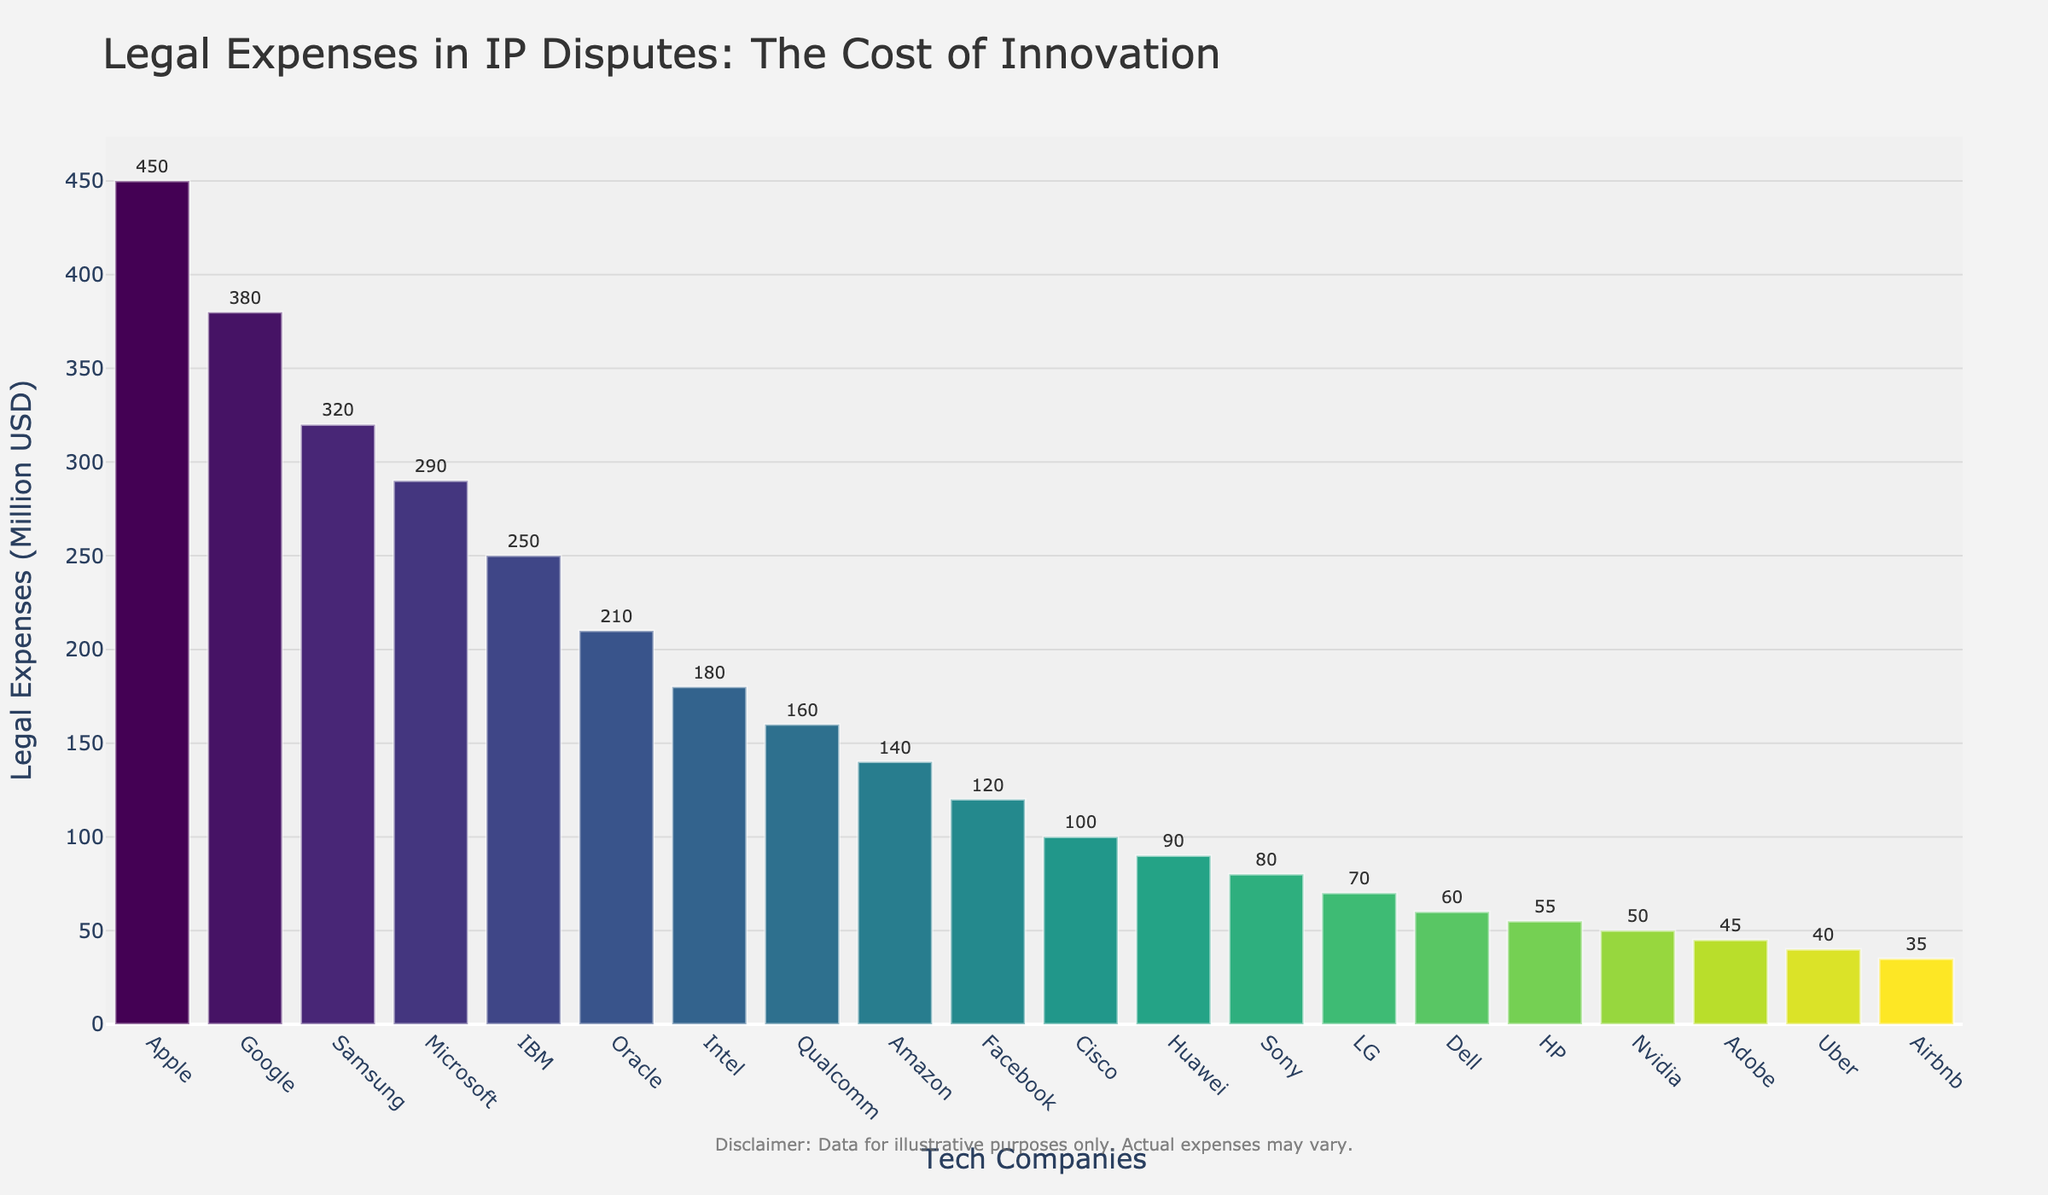What company has the highest legal expenses? The bar showing Apple is the tallest, indicating it has the highest legal expenses among the tech companies listed.
Answer: Apple What is the total legal expense for the top three companies? Add the legal expenses of Apple (450 Million USD), Google (380 Million USD), and Samsung (320 Million USD): 450 + 380 + 320 = 1150.
Answer: 1150 Among Facebook, Uber, and Airbnb, which company has the lowest legal expenses? Compare the legal expenses of the three companies: Facebook (120 Million USD), Uber (40 Million USD), and Airbnb (35 Million USD). The bar for Airbnb is the shortest among the three.
Answer: Airbnb Is Oracle's legal expense higher than Intel's? Oracle has 210 Million USD and Intel has 180 Million USD. Since 210 > 180, Oracle's legal expense is higher.
Answer: Yes What's the average legal expense for Amazon, Facebook, and Cisco? Sum the legal expenses of Amazon (140 Million USD), Facebook (120 Million USD), and Cisco (100 Million USD), then divide by 3: (140 + 120 + 100) / 3 = 360 / 3 = 120.
Answer: 120 How many companies have legal expenses above 300 Million USD? By counting the bars above the 300 Million USD mark: Apple, Google, and Samsung. There are three companies.
Answer: 3 Which company has legal expenses colored the darkest in the color scale? The bar for Apple is visually the darkest in the Viridis color scale used.
Answer: Apple Does Nvidia spend more on legal expenses than Adobe? Nvidia has 50 Million USD in legal expenses, while Adobe has 45 Million USD. Since 50 > 45, Nvidia spends more.
Answer: Yes What is the difference in legal expenses between Microsoft and Oracle? Subtract Oracle's legal expense (210 Million USD) from Microsoft's (290 Million USD): 290 - 210 = 80.
Answer: 80 Are there more companies with legal expenses above 100 Million USD or below 100 Million USD? Count companies above 100 Million USD: Apple, Google, Samsung, Microsoft, IBM, Oracle, Intel, Qualcomm, Amazon, Facebook. Total: 10. Count companies below 100 Million USD: Cisco, Huawei, Sony, LG, Dell, HP, Nvidia, Adobe, Uber, Airbnb. Total: 10. Both groups have the same number of companies.
Answer: Equal 